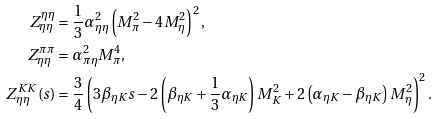Convert formula to latex. <formula><loc_0><loc_0><loc_500><loc_500>Z _ { \eta \eta } ^ { \eta \eta } & = \frac { 1 } { 3 } \alpha _ { \eta \eta } ^ { 2 } \left ( M _ { \pi } ^ { 2 } - 4 M _ { \eta } ^ { 2 } \right ) ^ { 2 } , \\ Z ^ { \pi \pi } _ { \eta \eta } & = \alpha _ { \pi \eta } ^ { 2 } M _ { \pi } ^ { 4 } , \\ Z ^ { K K } _ { \eta \eta } ( s ) & = \frac { 3 } { 4 } \left ( 3 \beta _ { \eta K } s - 2 \left ( \beta _ { \eta K } + \frac { 1 } { 3 } \alpha _ { \eta K } \right ) M _ { K } ^ { 2 } + 2 \left ( \alpha _ { \eta K } - \beta _ { \eta K } \right ) M _ { \eta } ^ { 2 } \right ) ^ { 2 } .</formula> 